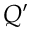<formula> <loc_0><loc_0><loc_500><loc_500>Q ^ { \prime }</formula> 